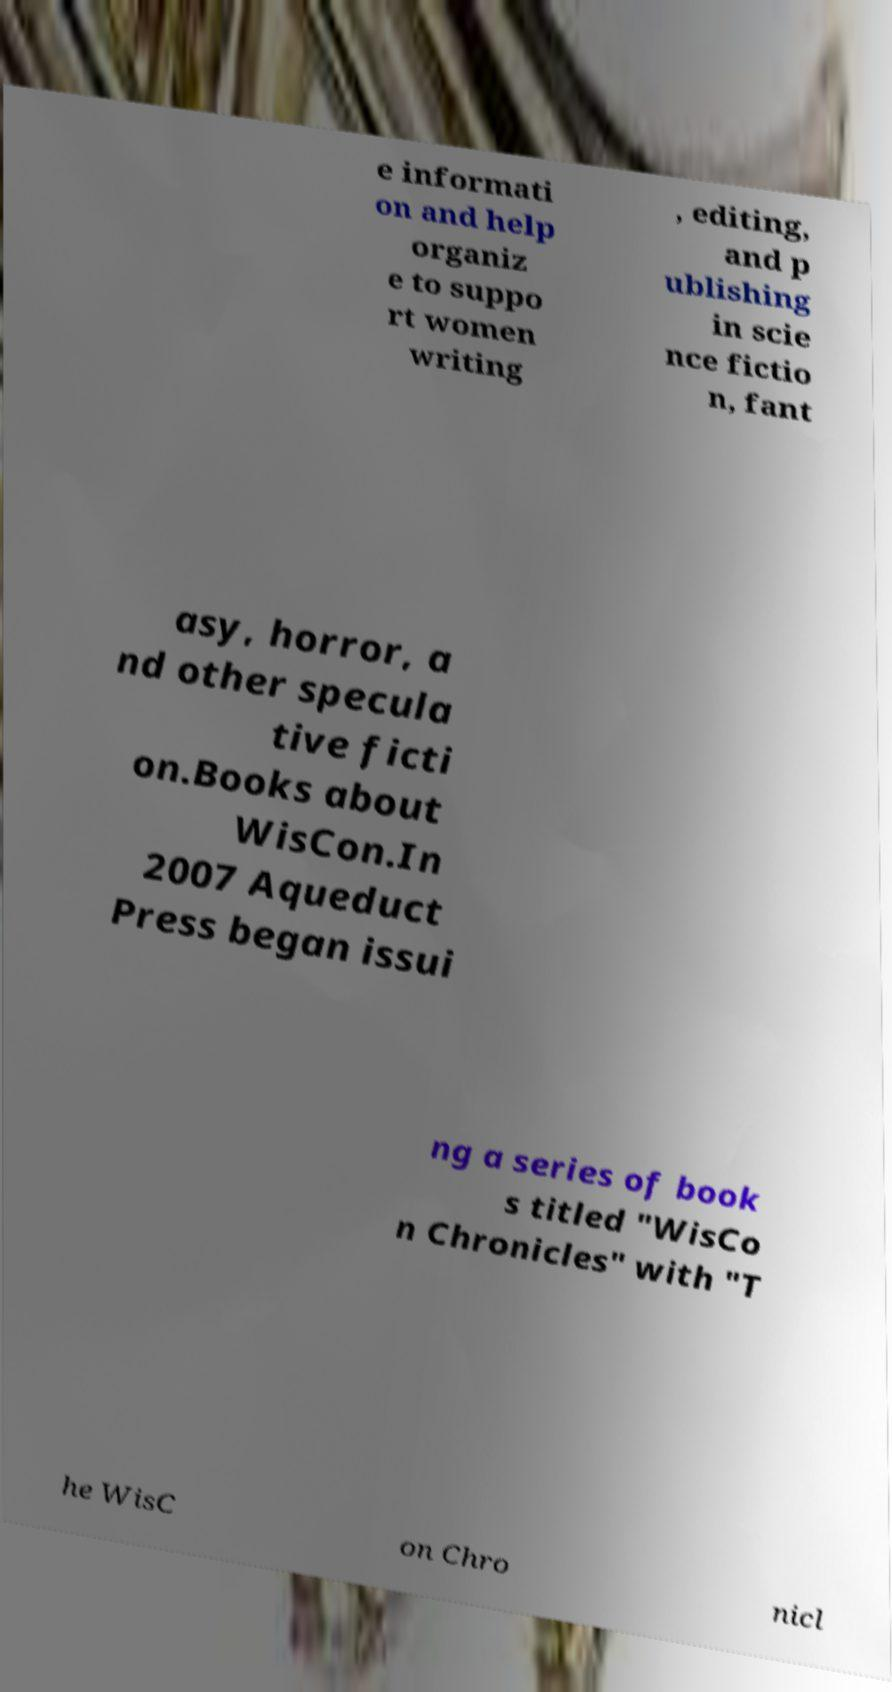Please read and relay the text visible in this image. What does it say? e informati on and help organiz e to suppo rt women writing , editing, and p ublishing in scie nce fictio n, fant asy, horror, a nd other specula tive ficti on.Books about WisCon.In 2007 Aqueduct Press began issui ng a series of book s titled "WisCo n Chronicles" with "T he WisC on Chro nicl 